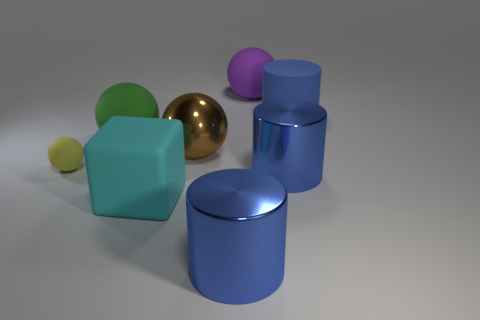Subtract all blue spheres. Subtract all red cylinders. How many spheres are left? 4 Add 2 large blue rubber cylinders. How many objects exist? 10 Subtract all cubes. How many objects are left? 7 Add 2 small objects. How many small objects are left? 3 Add 4 matte cylinders. How many matte cylinders exist? 5 Subtract 0 purple cylinders. How many objects are left? 8 Subtract all cyan blocks. Subtract all big rubber objects. How many objects are left? 3 